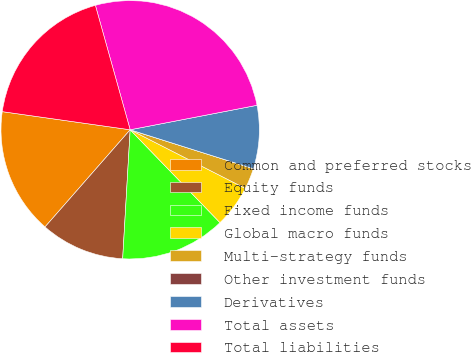<chart> <loc_0><loc_0><loc_500><loc_500><pie_chart><fcel>Common and preferred stocks<fcel>Equity funds<fcel>Fixed income funds<fcel>Global macro funds<fcel>Multi-strategy funds<fcel>Other investment funds<fcel>Derivatives<fcel>Total assets<fcel>Total liabilities<nl><fcel>15.79%<fcel>10.53%<fcel>13.16%<fcel>5.27%<fcel>2.63%<fcel>0.0%<fcel>7.9%<fcel>26.31%<fcel>18.42%<nl></chart> 